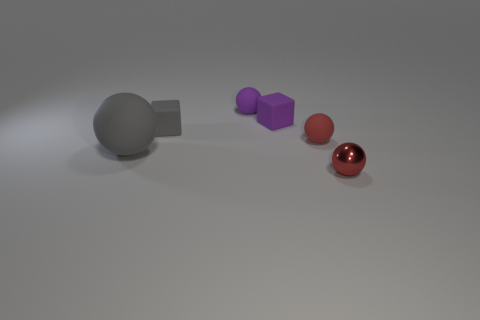Add 1 tiny objects. How many objects exist? 7 Subtract all tiny spheres. How many spheres are left? 1 Subtract all red spheres. How many spheres are left? 2 Subtract all red cylinders. How many red balls are left? 2 Subtract all spheres. How many objects are left? 2 Subtract 1 blocks. How many blocks are left? 1 Subtract all small metal balls. Subtract all large objects. How many objects are left? 4 Add 6 tiny metal objects. How many tiny metal objects are left? 7 Add 6 gray rubber things. How many gray rubber things exist? 8 Subtract 0 gray cylinders. How many objects are left? 6 